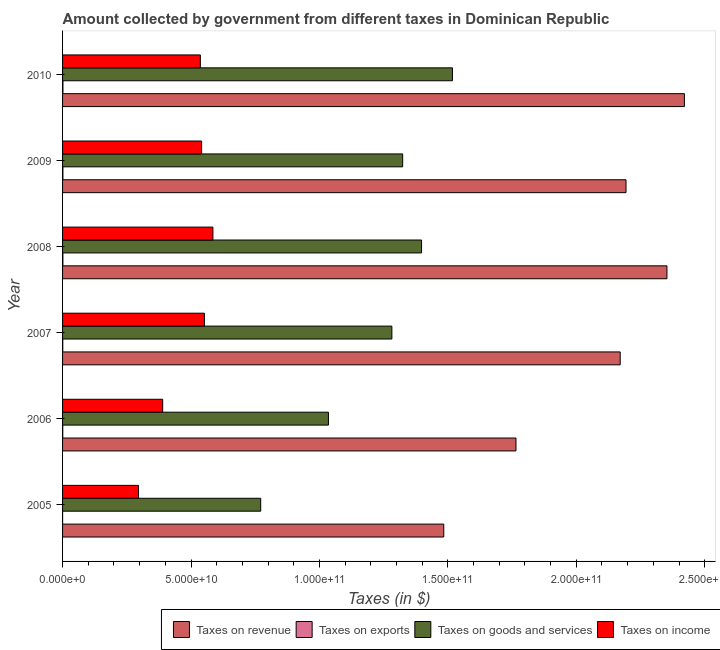How many groups of bars are there?
Give a very brief answer. 6. Are the number of bars per tick equal to the number of legend labels?
Your response must be concise. Yes. How many bars are there on the 3rd tick from the top?
Provide a short and direct response. 4. How many bars are there on the 6th tick from the bottom?
Provide a succinct answer. 4. What is the amount collected as tax on exports in 2008?
Offer a very short reply. 1.28e+08. Across all years, what is the maximum amount collected as tax on exports?
Keep it short and to the point. 1.46e+08. Across all years, what is the minimum amount collected as tax on revenue?
Provide a succinct answer. 1.48e+11. In which year was the amount collected as tax on exports maximum?
Provide a succinct answer. 2010. In which year was the amount collected as tax on income minimum?
Your answer should be compact. 2005. What is the total amount collected as tax on income in the graph?
Provide a succinct answer. 2.90e+11. What is the difference between the amount collected as tax on goods in 2005 and that in 2009?
Offer a terse response. -5.53e+1. What is the difference between the amount collected as tax on goods in 2006 and the amount collected as tax on income in 2008?
Your answer should be very brief. 4.50e+1. What is the average amount collected as tax on exports per year?
Make the answer very short. 9.52e+07. In the year 2010, what is the difference between the amount collected as tax on exports and amount collected as tax on revenue?
Make the answer very short. -2.42e+11. What is the ratio of the amount collected as tax on revenue in 2006 to that in 2010?
Your answer should be very brief. 0.73. Is the amount collected as tax on exports in 2008 less than that in 2009?
Offer a terse response. Yes. What is the difference between the highest and the second highest amount collected as tax on exports?
Provide a short and direct response. 1.46e+07. What is the difference between the highest and the lowest amount collected as tax on goods?
Give a very brief answer. 7.47e+1. Is the sum of the amount collected as tax on income in 2006 and 2010 greater than the maximum amount collected as tax on revenue across all years?
Your answer should be compact. No. Is it the case that in every year, the sum of the amount collected as tax on goods and amount collected as tax on revenue is greater than the sum of amount collected as tax on exports and amount collected as tax on income?
Offer a terse response. Yes. What does the 2nd bar from the top in 2006 represents?
Your answer should be very brief. Taxes on goods and services. What does the 3rd bar from the bottom in 2007 represents?
Your answer should be very brief. Taxes on goods and services. Is it the case that in every year, the sum of the amount collected as tax on revenue and amount collected as tax on exports is greater than the amount collected as tax on goods?
Provide a short and direct response. Yes. Are the values on the major ticks of X-axis written in scientific E-notation?
Your answer should be compact. Yes. Does the graph contain any zero values?
Ensure brevity in your answer.  No. Does the graph contain grids?
Ensure brevity in your answer.  No. How many legend labels are there?
Make the answer very short. 4. How are the legend labels stacked?
Provide a succinct answer. Horizontal. What is the title of the graph?
Your answer should be compact. Amount collected by government from different taxes in Dominican Republic. Does "Compensation of employees" appear as one of the legend labels in the graph?
Offer a terse response. No. What is the label or title of the X-axis?
Provide a short and direct response. Taxes (in $). What is the Taxes (in $) of Taxes on revenue in 2005?
Offer a terse response. 1.48e+11. What is the Taxes (in $) of Taxes on exports in 2005?
Give a very brief answer. 1.36e+07. What is the Taxes (in $) in Taxes on goods and services in 2005?
Provide a short and direct response. 7.71e+1. What is the Taxes (in $) in Taxes on income in 2005?
Your answer should be very brief. 2.96e+1. What is the Taxes (in $) of Taxes on revenue in 2006?
Make the answer very short. 1.77e+11. What is the Taxes (in $) in Taxes on exports in 2006?
Your answer should be very brief. 6.90e+07. What is the Taxes (in $) of Taxes on goods and services in 2006?
Your answer should be compact. 1.04e+11. What is the Taxes (in $) of Taxes on income in 2006?
Make the answer very short. 3.90e+1. What is the Taxes (in $) of Taxes on revenue in 2007?
Your response must be concise. 2.17e+11. What is the Taxes (in $) in Taxes on exports in 2007?
Your answer should be compact. 8.25e+07. What is the Taxes (in $) in Taxes on goods and services in 2007?
Offer a terse response. 1.28e+11. What is the Taxes (in $) of Taxes on income in 2007?
Offer a terse response. 5.52e+1. What is the Taxes (in $) of Taxes on revenue in 2008?
Your answer should be compact. 2.35e+11. What is the Taxes (in $) of Taxes on exports in 2008?
Offer a terse response. 1.28e+08. What is the Taxes (in $) in Taxes on goods and services in 2008?
Offer a terse response. 1.40e+11. What is the Taxes (in $) in Taxes on income in 2008?
Offer a very short reply. 5.85e+1. What is the Taxes (in $) in Taxes on revenue in 2009?
Provide a succinct answer. 2.19e+11. What is the Taxes (in $) in Taxes on exports in 2009?
Your answer should be very brief. 1.32e+08. What is the Taxes (in $) in Taxes on goods and services in 2009?
Offer a very short reply. 1.32e+11. What is the Taxes (in $) in Taxes on income in 2009?
Offer a terse response. 5.41e+1. What is the Taxes (in $) of Taxes on revenue in 2010?
Keep it short and to the point. 2.42e+11. What is the Taxes (in $) of Taxes on exports in 2010?
Ensure brevity in your answer.  1.46e+08. What is the Taxes (in $) in Taxes on goods and services in 2010?
Provide a short and direct response. 1.52e+11. What is the Taxes (in $) of Taxes on income in 2010?
Offer a terse response. 5.36e+1. Across all years, what is the maximum Taxes (in $) of Taxes on revenue?
Make the answer very short. 2.42e+11. Across all years, what is the maximum Taxes (in $) of Taxes on exports?
Ensure brevity in your answer.  1.46e+08. Across all years, what is the maximum Taxes (in $) of Taxes on goods and services?
Provide a succinct answer. 1.52e+11. Across all years, what is the maximum Taxes (in $) in Taxes on income?
Ensure brevity in your answer.  5.85e+1. Across all years, what is the minimum Taxes (in $) of Taxes on revenue?
Give a very brief answer. 1.48e+11. Across all years, what is the minimum Taxes (in $) in Taxes on exports?
Your answer should be very brief. 1.36e+07. Across all years, what is the minimum Taxes (in $) in Taxes on goods and services?
Your answer should be very brief. 7.71e+1. Across all years, what is the minimum Taxes (in $) in Taxes on income?
Your response must be concise. 2.96e+1. What is the total Taxes (in $) in Taxes on revenue in the graph?
Provide a succinct answer. 1.24e+12. What is the total Taxes (in $) of Taxes on exports in the graph?
Your response must be concise. 5.71e+08. What is the total Taxes (in $) in Taxes on goods and services in the graph?
Keep it short and to the point. 7.33e+11. What is the total Taxes (in $) of Taxes on income in the graph?
Offer a very short reply. 2.90e+11. What is the difference between the Taxes (in $) in Taxes on revenue in 2005 and that in 2006?
Offer a terse response. -2.81e+1. What is the difference between the Taxes (in $) in Taxes on exports in 2005 and that in 2006?
Your answer should be compact. -5.54e+07. What is the difference between the Taxes (in $) in Taxes on goods and services in 2005 and that in 2006?
Your answer should be very brief. -2.64e+1. What is the difference between the Taxes (in $) in Taxes on income in 2005 and that in 2006?
Ensure brevity in your answer.  -9.41e+09. What is the difference between the Taxes (in $) of Taxes on revenue in 2005 and that in 2007?
Your answer should be compact. -6.87e+1. What is the difference between the Taxes (in $) in Taxes on exports in 2005 and that in 2007?
Provide a succinct answer. -6.89e+07. What is the difference between the Taxes (in $) of Taxes on goods and services in 2005 and that in 2007?
Your answer should be very brief. -5.11e+1. What is the difference between the Taxes (in $) of Taxes on income in 2005 and that in 2007?
Give a very brief answer. -2.57e+1. What is the difference between the Taxes (in $) in Taxes on revenue in 2005 and that in 2008?
Make the answer very short. -8.69e+1. What is the difference between the Taxes (in $) in Taxes on exports in 2005 and that in 2008?
Offer a very short reply. -1.15e+08. What is the difference between the Taxes (in $) of Taxes on goods and services in 2005 and that in 2008?
Make the answer very short. -6.26e+1. What is the difference between the Taxes (in $) of Taxes on income in 2005 and that in 2008?
Offer a very short reply. -2.90e+1. What is the difference between the Taxes (in $) in Taxes on revenue in 2005 and that in 2009?
Your response must be concise. -7.10e+1. What is the difference between the Taxes (in $) in Taxes on exports in 2005 and that in 2009?
Make the answer very short. -1.18e+08. What is the difference between the Taxes (in $) in Taxes on goods and services in 2005 and that in 2009?
Ensure brevity in your answer.  -5.53e+1. What is the difference between the Taxes (in $) of Taxes on income in 2005 and that in 2009?
Make the answer very short. -2.46e+1. What is the difference between the Taxes (in $) of Taxes on revenue in 2005 and that in 2010?
Provide a short and direct response. -9.37e+1. What is the difference between the Taxes (in $) of Taxes on exports in 2005 and that in 2010?
Provide a succinct answer. -1.33e+08. What is the difference between the Taxes (in $) of Taxes on goods and services in 2005 and that in 2010?
Your response must be concise. -7.47e+1. What is the difference between the Taxes (in $) of Taxes on income in 2005 and that in 2010?
Your response must be concise. -2.41e+1. What is the difference between the Taxes (in $) in Taxes on revenue in 2006 and that in 2007?
Give a very brief answer. -4.06e+1. What is the difference between the Taxes (in $) of Taxes on exports in 2006 and that in 2007?
Make the answer very short. -1.35e+07. What is the difference between the Taxes (in $) of Taxes on goods and services in 2006 and that in 2007?
Your answer should be very brief. -2.47e+1. What is the difference between the Taxes (in $) of Taxes on income in 2006 and that in 2007?
Keep it short and to the point. -1.63e+1. What is the difference between the Taxes (in $) of Taxes on revenue in 2006 and that in 2008?
Your answer should be compact. -5.88e+1. What is the difference between the Taxes (in $) in Taxes on exports in 2006 and that in 2008?
Your response must be concise. -5.92e+07. What is the difference between the Taxes (in $) of Taxes on goods and services in 2006 and that in 2008?
Give a very brief answer. -3.62e+1. What is the difference between the Taxes (in $) in Taxes on income in 2006 and that in 2008?
Your answer should be very brief. -1.96e+1. What is the difference between the Taxes (in $) in Taxes on revenue in 2006 and that in 2009?
Your answer should be very brief. -4.28e+1. What is the difference between the Taxes (in $) in Taxes on exports in 2006 and that in 2009?
Give a very brief answer. -6.27e+07. What is the difference between the Taxes (in $) in Taxes on goods and services in 2006 and that in 2009?
Provide a short and direct response. -2.89e+1. What is the difference between the Taxes (in $) of Taxes on income in 2006 and that in 2009?
Offer a very short reply. -1.51e+1. What is the difference between the Taxes (in $) of Taxes on revenue in 2006 and that in 2010?
Ensure brevity in your answer.  -6.56e+1. What is the difference between the Taxes (in $) of Taxes on exports in 2006 and that in 2010?
Make the answer very short. -7.73e+07. What is the difference between the Taxes (in $) of Taxes on goods and services in 2006 and that in 2010?
Give a very brief answer. -4.83e+1. What is the difference between the Taxes (in $) of Taxes on income in 2006 and that in 2010?
Make the answer very short. -1.47e+1. What is the difference between the Taxes (in $) of Taxes on revenue in 2007 and that in 2008?
Your answer should be very brief. -1.82e+1. What is the difference between the Taxes (in $) of Taxes on exports in 2007 and that in 2008?
Make the answer very short. -4.56e+07. What is the difference between the Taxes (in $) of Taxes on goods and services in 2007 and that in 2008?
Ensure brevity in your answer.  -1.16e+1. What is the difference between the Taxes (in $) of Taxes on income in 2007 and that in 2008?
Your answer should be compact. -3.30e+09. What is the difference between the Taxes (in $) of Taxes on revenue in 2007 and that in 2009?
Ensure brevity in your answer.  -2.26e+09. What is the difference between the Taxes (in $) of Taxes on exports in 2007 and that in 2009?
Provide a succinct answer. -4.92e+07. What is the difference between the Taxes (in $) of Taxes on goods and services in 2007 and that in 2009?
Your response must be concise. -4.20e+09. What is the difference between the Taxes (in $) of Taxes on income in 2007 and that in 2009?
Ensure brevity in your answer.  1.10e+09. What is the difference between the Taxes (in $) in Taxes on revenue in 2007 and that in 2010?
Keep it short and to the point. -2.50e+1. What is the difference between the Taxes (in $) of Taxes on exports in 2007 and that in 2010?
Provide a short and direct response. -6.38e+07. What is the difference between the Taxes (in $) in Taxes on goods and services in 2007 and that in 2010?
Make the answer very short. -2.36e+1. What is the difference between the Taxes (in $) in Taxes on income in 2007 and that in 2010?
Ensure brevity in your answer.  1.59e+09. What is the difference between the Taxes (in $) in Taxes on revenue in 2008 and that in 2009?
Your answer should be compact. 1.59e+1. What is the difference between the Taxes (in $) in Taxes on exports in 2008 and that in 2009?
Your response must be concise. -3.52e+06. What is the difference between the Taxes (in $) in Taxes on goods and services in 2008 and that in 2009?
Provide a succinct answer. 7.36e+09. What is the difference between the Taxes (in $) in Taxes on income in 2008 and that in 2009?
Offer a very short reply. 4.41e+09. What is the difference between the Taxes (in $) of Taxes on revenue in 2008 and that in 2010?
Keep it short and to the point. -6.79e+09. What is the difference between the Taxes (in $) of Taxes on exports in 2008 and that in 2010?
Your answer should be very brief. -1.82e+07. What is the difference between the Taxes (in $) of Taxes on goods and services in 2008 and that in 2010?
Give a very brief answer. -1.20e+1. What is the difference between the Taxes (in $) of Taxes on income in 2008 and that in 2010?
Ensure brevity in your answer.  4.89e+09. What is the difference between the Taxes (in $) in Taxes on revenue in 2009 and that in 2010?
Offer a very short reply. -2.27e+1. What is the difference between the Taxes (in $) in Taxes on exports in 2009 and that in 2010?
Your response must be concise. -1.46e+07. What is the difference between the Taxes (in $) in Taxes on goods and services in 2009 and that in 2010?
Provide a short and direct response. -1.94e+1. What is the difference between the Taxes (in $) in Taxes on income in 2009 and that in 2010?
Ensure brevity in your answer.  4.84e+08. What is the difference between the Taxes (in $) in Taxes on revenue in 2005 and the Taxes (in $) in Taxes on exports in 2006?
Ensure brevity in your answer.  1.48e+11. What is the difference between the Taxes (in $) of Taxes on revenue in 2005 and the Taxes (in $) of Taxes on goods and services in 2006?
Keep it short and to the point. 4.49e+1. What is the difference between the Taxes (in $) in Taxes on revenue in 2005 and the Taxes (in $) in Taxes on income in 2006?
Your answer should be compact. 1.09e+11. What is the difference between the Taxes (in $) in Taxes on exports in 2005 and the Taxes (in $) in Taxes on goods and services in 2006?
Ensure brevity in your answer.  -1.04e+11. What is the difference between the Taxes (in $) of Taxes on exports in 2005 and the Taxes (in $) of Taxes on income in 2006?
Give a very brief answer. -3.90e+1. What is the difference between the Taxes (in $) of Taxes on goods and services in 2005 and the Taxes (in $) of Taxes on income in 2006?
Your response must be concise. 3.82e+1. What is the difference between the Taxes (in $) in Taxes on revenue in 2005 and the Taxes (in $) in Taxes on exports in 2007?
Keep it short and to the point. 1.48e+11. What is the difference between the Taxes (in $) of Taxes on revenue in 2005 and the Taxes (in $) of Taxes on goods and services in 2007?
Provide a short and direct response. 2.02e+1. What is the difference between the Taxes (in $) of Taxes on revenue in 2005 and the Taxes (in $) of Taxes on income in 2007?
Make the answer very short. 9.32e+1. What is the difference between the Taxes (in $) in Taxes on exports in 2005 and the Taxes (in $) in Taxes on goods and services in 2007?
Keep it short and to the point. -1.28e+11. What is the difference between the Taxes (in $) of Taxes on exports in 2005 and the Taxes (in $) of Taxes on income in 2007?
Your answer should be compact. -5.52e+1. What is the difference between the Taxes (in $) of Taxes on goods and services in 2005 and the Taxes (in $) of Taxes on income in 2007?
Give a very brief answer. 2.19e+1. What is the difference between the Taxes (in $) of Taxes on revenue in 2005 and the Taxes (in $) of Taxes on exports in 2008?
Ensure brevity in your answer.  1.48e+11. What is the difference between the Taxes (in $) in Taxes on revenue in 2005 and the Taxes (in $) in Taxes on goods and services in 2008?
Provide a short and direct response. 8.65e+09. What is the difference between the Taxes (in $) of Taxes on revenue in 2005 and the Taxes (in $) of Taxes on income in 2008?
Provide a short and direct response. 8.99e+1. What is the difference between the Taxes (in $) in Taxes on exports in 2005 and the Taxes (in $) in Taxes on goods and services in 2008?
Provide a succinct answer. -1.40e+11. What is the difference between the Taxes (in $) of Taxes on exports in 2005 and the Taxes (in $) of Taxes on income in 2008?
Offer a very short reply. -5.85e+1. What is the difference between the Taxes (in $) of Taxes on goods and services in 2005 and the Taxes (in $) of Taxes on income in 2008?
Ensure brevity in your answer.  1.86e+1. What is the difference between the Taxes (in $) of Taxes on revenue in 2005 and the Taxes (in $) of Taxes on exports in 2009?
Provide a short and direct response. 1.48e+11. What is the difference between the Taxes (in $) in Taxes on revenue in 2005 and the Taxes (in $) in Taxes on goods and services in 2009?
Keep it short and to the point. 1.60e+1. What is the difference between the Taxes (in $) of Taxes on revenue in 2005 and the Taxes (in $) of Taxes on income in 2009?
Provide a succinct answer. 9.43e+1. What is the difference between the Taxes (in $) of Taxes on exports in 2005 and the Taxes (in $) of Taxes on goods and services in 2009?
Offer a very short reply. -1.32e+11. What is the difference between the Taxes (in $) in Taxes on exports in 2005 and the Taxes (in $) in Taxes on income in 2009?
Offer a very short reply. -5.41e+1. What is the difference between the Taxes (in $) in Taxes on goods and services in 2005 and the Taxes (in $) in Taxes on income in 2009?
Your answer should be compact. 2.30e+1. What is the difference between the Taxes (in $) in Taxes on revenue in 2005 and the Taxes (in $) in Taxes on exports in 2010?
Your answer should be compact. 1.48e+11. What is the difference between the Taxes (in $) in Taxes on revenue in 2005 and the Taxes (in $) in Taxes on goods and services in 2010?
Your answer should be very brief. -3.39e+09. What is the difference between the Taxes (in $) in Taxes on revenue in 2005 and the Taxes (in $) in Taxes on income in 2010?
Offer a very short reply. 9.48e+1. What is the difference between the Taxes (in $) in Taxes on exports in 2005 and the Taxes (in $) in Taxes on goods and services in 2010?
Your answer should be compact. -1.52e+11. What is the difference between the Taxes (in $) of Taxes on exports in 2005 and the Taxes (in $) of Taxes on income in 2010?
Your answer should be very brief. -5.36e+1. What is the difference between the Taxes (in $) in Taxes on goods and services in 2005 and the Taxes (in $) in Taxes on income in 2010?
Your answer should be compact. 2.35e+1. What is the difference between the Taxes (in $) of Taxes on revenue in 2006 and the Taxes (in $) of Taxes on exports in 2007?
Make the answer very short. 1.76e+11. What is the difference between the Taxes (in $) of Taxes on revenue in 2006 and the Taxes (in $) of Taxes on goods and services in 2007?
Offer a terse response. 4.83e+1. What is the difference between the Taxes (in $) in Taxes on revenue in 2006 and the Taxes (in $) in Taxes on income in 2007?
Provide a short and direct response. 1.21e+11. What is the difference between the Taxes (in $) of Taxes on exports in 2006 and the Taxes (in $) of Taxes on goods and services in 2007?
Ensure brevity in your answer.  -1.28e+11. What is the difference between the Taxes (in $) of Taxes on exports in 2006 and the Taxes (in $) of Taxes on income in 2007?
Your response must be concise. -5.52e+1. What is the difference between the Taxes (in $) of Taxes on goods and services in 2006 and the Taxes (in $) of Taxes on income in 2007?
Give a very brief answer. 4.83e+1. What is the difference between the Taxes (in $) of Taxes on revenue in 2006 and the Taxes (in $) of Taxes on exports in 2008?
Keep it short and to the point. 1.76e+11. What is the difference between the Taxes (in $) of Taxes on revenue in 2006 and the Taxes (in $) of Taxes on goods and services in 2008?
Your answer should be compact. 3.68e+1. What is the difference between the Taxes (in $) in Taxes on revenue in 2006 and the Taxes (in $) in Taxes on income in 2008?
Provide a succinct answer. 1.18e+11. What is the difference between the Taxes (in $) in Taxes on exports in 2006 and the Taxes (in $) in Taxes on goods and services in 2008?
Keep it short and to the point. -1.40e+11. What is the difference between the Taxes (in $) in Taxes on exports in 2006 and the Taxes (in $) in Taxes on income in 2008?
Provide a succinct answer. -5.85e+1. What is the difference between the Taxes (in $) of Taxes on goods and services in 2006 and the Taxes (in $) of Taxes on income in 2008?
Your answer should be compact. 4.50e+1. What is the difference between the Taxes (in $) of Taxes on revenue in 2006 and the Taxes (in $) of Taxes on exports in 2009?
Keep it short and to the point. 1.76e+11. What is the difference between the Taxes (in $) of Taxes on revenue in 2006 and the Taxes (in $) of Taxes on goods and services in 2009?
Make the answer very short. 4.41e+1. What is the difference between the Taxes (in $) of Taxes on revenue in 2006 and the Taxes (in $) of Taxes on income in 2009?
Your response must be concise. 1.22e+11. What is the difference between the Taxes (in $) in Taxes on exports in 2006 and the Taxes (in $) in Taxes on goods and services in 2009?
Provide a succinct answer. -1.32e+11. What is the difference between the Taxes (in $) in Taxes on exports in 2006 and the Taxes (in $) in Taxes on income in 2009?
Ensure brevity in your answer.  -5.41e+1. What is the difference between the Taxes (in $) of Taxes on goods and services in 2006 and the Taxes (in $) of Taxes on income in 2009?
Your answer should be compact. 4.94e+1. What is the difference between the Taxes (in $) in Taxes on revenue in 2006 and the Taxes (in $) in Taxes on exports in 2010?
Offer a very short reply. 1.76e+11. What is the difference between the Taxes (in $) in Taxes on revenue in 2006 and the Taxes (in $) in Taxes on goods and services in 2010?
Keep it short and to the point. 2.47e+1. What is the difference between the Taxes (in $) in Taxes on revenue in 2006 and the Taxes (in $) in Taxes on income in 2010?
Your answer should be compact. 1.23e+11. What is the difference between the Taxes (in $) of Taxes on exports in 2006 and the Taxes (in $) of Taxes on goods and services in 2010?
Your answer should be compact. -1.52e+11. What is the difference between the Taxes (in $) of Taxes on exports in 2006 and the Taxes (in $) of Taxes on income in 2010?
Provide a short and direct response. -5.36e+1. What is the difference between the Taxes (in $) of Taxes on goods and services in 2006 and the Taxes (in $) of Taxes on income in 2010?
Offer a very short reply. 4.99e+1. What is the difference between the Taxes (in $) in Taxes on revenue in 2007 and the Taxes (in $) in Taxes on exports in 2008?
Your answer should be very brief. 2.17e+11. What is the difference between the Taxes (in $) in Taxes on revenue in 2007 and the Taxes (in $) in Taxes on goods and services in 2008?
Your answer should be compact. 7.73e+1. What is the difference between the Taxes (in $) of Taxes on revenue in 2007 and the Taxes (in $) of Taxes on income in 2008?
Give a very brief answer. 1.59e+11. What is the difference between the Taxes (in $) in Taxes on exports in 2007 and the Taxes (in $) in Taxes on goods and services in 2008?
Your response must be concise. -1.40e+11. What is the difference between the Taxes (in $) in Taxes on exports in 2007 and the Taxes (in $) in Taxes on income in 2008?
Offer a very short reply. -5.85e+1. What is the difference between the Taxes (in $) of Taxes on goods and services in 2007 and the Taxes (in $) of Taxes on income in 2008?
Your answer should be very brief. 6.97e+1. What is the difference between the Taxes (in $) of Taxes on revenue in 2007 and the Taxes (in $) of Taxes on exports in 2009?
Provide a short and direct response. 2.17e+11. What is the difference between the Taxes (in $) of Taxes on revenue in 2007 and the Taxes (in $) of Taxes on goods and services in 2009?
Offer a terse response. 8.47e+1. What is the difference between the Taxes (in $) of Taxes on revenue in 2007 and the Taxes (in $) of Taxes on income in 2009?
Your answer should be compact. 1.63e+11. What is the difference between the Taxes (in $) in Taxes on exports in 2007 and the Taxes (in $) in Taxes on goods and services in 2009?
Provide a succinct answer. -1.32e+11. What is the difference between the Taxes (in $) of Taxes on exports in 2007 and the Taxes (in $) of Taxes on income in 2009?
Your response must be concise. -5.40e+1. What is the difference between the Taxes (in $) in Taxes on goods and services in 2007 and the Taxes (in $) in Taxes on income in 2009?
Provide a succinct answer. 7.41e+1. What is the difference between the Taxes (in $) in Taxes on revenue in 2007 and the Taxes (in $) in Taxes on exports in 2010?
Offer a terse response. 2.17e+11. What is the difference between the Taxes (in $) in Taxes on revenue in 2007 and the Taxes (in $) in Taxes on goods and services in 2010?
Give a very brief answer. 6.53e+1. What is the difference between the Taxes (in $) of Taxes on revenue in 2007 and the Taxes (in $) of Taxes on income in 2010?
Make the answer very short. 1.63e+11. What is the difference between the Taxes (in $) in Taxes on exports in 2007 and the Taxes (in $) in Taxes on goods and services in 2010?
Keep it short and to the point. -1.52e+11. What is the difference between the Taxes (in $) of Taxes on exports in 2007 and the Taxes (in $) of Taxes on income in 2010?
Provide a short and direct response. -5.36e+1. What is the difference between the Taxes (in $) in Taxes on goods and services in 2007 and the Taxes (in $) in Taxes on income in 2010?
Your answer should be very brief. 7.46e+1. What is the difference between the Taxes (in $) of Taxes on revenue in 2008 and the Taxes (in $) of Taxes on exports in 2009?
Your answer should be very brief. 2.35e+11. What is the difference between the Taxes (in $) of Taxes on revenue in 2008 and the Taxes (in $) of Taxes on goods and services in 2009?
Offer a very short reply. 1.03e+11. What is the difference between the Taxes (in $) of Taxes on revenue in 2008 and the Taxes (in $) of Taxes on income in 2009?
Offer a very short reply. 1.81e+11. What is the difference between the Taxes (in $) in Taxes on exports in 2008 and the Taxes (in $) in Taxes on goods and services in 2009?
Your response must be concise. -1.32e+11. What is the difference between the Taxes (in $) of Taxes on exports in 2008 and the Taxes (in $) of Taxes on income in 2009?
Make the answer very short. -5.40e+1. What is the difference between the Taxes (in $) of Taxes on goods and services in 2008 and the Taxes (in $) of Taxes on income in 2009?
Offer a terse response. 8.56e+1. What is the difference between the Taxes (in $) in Taxes on revenue in 2008 and the Taxes (in $) in Taxes on exports in 2010?
Offer a very short reply. 2.35e+11. What is the difference between the Taxes (in $) of Taxes on revenue in 2008 and the Taxes (in $) of Taxes on goods and services in 2010?
Keep it short and to the point. 8.35e+1. What is the difference between the Taxes (in $) of Taxes on revenue in 2008 and the Taxes (in $) of Taxes on income in 2010?
Make the answer very short. 1.82e+11. What is the difference between the Taxes (in $) in Taxes on exports in 2008 and the Taxes (in $) in Taxes on goods and services in 2010?
Your answer should be compact. -1.52e+11. What is the difference between the Taxes (in $) in Taxes on exports in 2008 and the Taxes (in $) in Taxes on income in 2010?
Your response must be concise. -5.35e+1. What is the difference between the Taxes (in $) of Taxes on goods and services in 2008 and the Taxes (in $) of Taxes on income in 2010?
Offer a very short reply. 8.61e+1. What is the difference between the Taxes (in $) in Taxes on revenue in 2009 and the Taxes (in $) in Taxes on exports in 2010?
Provide a succinct answer. 2.19e+11. What is the difference between the Taxes (in $) of Taxes on revenue in 2009 and the Taxes (in $) of Taxes on goods and services in 2010?
Offer a very short reply. 6.76e+1. What is the difference between the Taxes (in $) of Taxes on revenue in 2009 and the Taxes (in $) of Taxes on income in 2010?
Make the answer very short. 1.66e+11. What is the difference between the Taxes (in $) of Taxes on exports in 2009 and the Taxes (in $) of Taxes on goods and services in 2010?
Keep it short and to the point. -1.52e+11. What is the difference between the Taxes (in $) of Taxes on exports in 2009 and the Taxes (in $) of Taxes on income in 2010?
Offer a very short reply. -5.35e+1. What is the difference between the Taxes (in $) of Taxes on goods and services in 2009 and the Taxes (in $) of Taxes on income in 2010?
Offer a terse response. 7.88e+1. What is the average Taxes (in $) of Taxes on revenue per year?
Ensure brevity in your answer.  2.06e+11. What is the average Taxes (in $) in Taxes on exports per year?
Offer a terse response. 9.52e+07. What is the average Taxes (in $) in Taxes on goods and services per year?
Make the answer very short. 1.22e+11. What is the average Taxes (in $) of Taxes on income per year?
Your answer should be compact. 4.83e+1. In the year 2005, what is the difference between the Taxes (in $) of Taxes on revenue and Taxes (in $) of Taxes on exports?
Your response must be concise. 1.48e+11. In the year 2005, what is the difference between the Taxes (in $) in Taxes on revenue and Taxes (in $) in Taxes on goods and services?
Provide a succinct answer. 7.13e+1. In the year 2005, what is the difference between the Taxes (in $) in Taxes on revenue and Taxes (in $) in Taxes on income?
Your response must be concise. 1.19e+11. In the year 2005, what is the difference between the Taxes (in $) of Taxes on exports and Taxes (in $) of Taxes on goods and services?
Offer a very short reply. -7.71e+1. In the year 2005, what is the difference between the Taxes (in $) of Taxes on exports and Taxes (in $) of Taxes on income?
Make the answer very short. -2.96e+1. In the year 2005, what is the difference between the Taxes (in $) in Taxes on goods and services and Taxes (in $) in Taxes on income?
Offer a very short reply. 4.76e+1. In the year 2006, what is the difference between the Taxes (in $) in Taxes on revenue and Taxes (in $) in Taxes on exports?
Offer a terse response. 1.76e+11. In the year 2006, what is the difference between the Taxes (in $) of Taxes on revenue and Taxes (in $) of Taxes on goods and services?
Provide a short and direct response. 7.30e+1. In the year 2006, what is the difference between the Taxes (in $) of Taxes on revenue and Taxes (in $) of Taxes on income?
Provide a short and direct response. 1.38e+11. In the year 2006, what is the difference between the Taxes (in $) of Taxes on exports and Taxes (in $) of Taxes on goods and services?
Offer a very short reply. -1.03e+11. In the year 2006, what is the difference between the Taxes (in $) of Taxes on exports and Taxes (in $) of Taxes on income?
Provide a succinct answer. -3.89e+1. In the year 2006, what is the difference between the Taxes (in $) in Taxes on goods and services and Taxes (in $) in Taxes on income?
Make the answer very short. 6.45e+1. In the year 2007, what is the difference between the Taxes (in $) in Taxes on revenue and Taxes (in $) in Taxes on exports?
Make the answer very short. 2.17e+11. In the year 2007, what is the difference between the Taxes (in $) of Taxes on revenue and Taxes (in $) of Taxes on goods and services?
Offer a terse response. 8.89e+1. In the year 2007, what is the difference between the Taxes (in $) in Taxes on revenue and Taxes (in $) in Taxes on income?
Offer a very short reply. 1.62e+11. In the year 2007, what is the difference between the Taxes (in $) of Taxes on exports and Taxes (in $) of Taxes on goods and services?
Keep it short and to the point. -1.28e+11. In the year 2007, what is the difference between the Taxes (in $) of Taxes on exports and Taxes (in $) of Taxes on income?
Offer a very short reply. -5.51e+1. In the year 2007, what is the difference between the Taxes (in $) of Taxes on goods and services and Taxes (in $) of Taxes on income?
Keep it short and to the point. 7.30e+1. In the year 2008, what is the difference between the Taxes (in $) of Taxes on revenue and Taxes (in $) of Taxes on exports?
Give a very brief answer. 2.35e+11. In the year 2008, what is the difference between the Taxes (in $) of Taxes on revenue and Taxes (in $) of Taxes on goods and services?
Offer a terse response. 9.55e+1. In the year 2008, what is the difference between the Taxes (in $) in Taxes on revenue and Taxes (in $) in Taxes on income?
Keep it short and to the point. 1.77e+11. In the year 2008, what is the difference between the Taxes (in $) of Taxes on exports and Taxes (in $) of Taxes on goods and services?
Your response must be concise. -1.40e+11. In the year 2008, what is the difference between the Taxes (in $) in Taxes on exports and Taxes (in $) in Taxes on income?
Keep it short and to the point. -5.84e+1. In the year 2008, what is the difference between the Taxes (in $) of Taxes on goods and services and Taxes (in $) of Taxes on income?
Provide a short and direct response. 8.12e+1. In the year 2009, what is the difference between the Taxes (in $) of Taxes on revenue and Taxes (in $) of Taxes on exports?
Provide a short and direct response. 2.19e+11. In the year 2009, what is the difference between the Taxes (in $) in Taxes on revenue and Taxes (in $) in Taxes on goods and services?
Keep it short and to the point. 8.70e+1. In the year 2009, what is the difference between the Taxes (in $) in Taxes on revenue and Taxes (in $) in Taxes on income?
Keep it short and to the point. 1.65e+11. In the year 2009, what is the difference between the Taxes (in $) in Taxes on exports and Taxes (in $) in Taxes on goods and services?
Your answer should be very brief. -1.32e+11. In the year 2009, what is the difference between the Taxes (in $) in Taxes on exports and Taxes (in $) in Taxes on income?
Offer a terse response. -5.40e+1. In the year 2009, what is the difference between the Taxes (in $) of Taxes on goods and services and Taxes (in $) of Taxes on income?
Make the answer very short. 7.83e+1. In the year 2010, what is the difference between the Taxes (in $) in Taxes on revenue and Taxes (in $) in Taxes on exports?
Give a very brief answer. 2.42e+11. In the year 2010, what is the difference between the Taxes (in $) in Taxes on revenue and Taxes (in $) in Taxes on goods and services?
Make the answer very short. 9.03e+1. In the year 2010, what is the difference between the Taxes (in $) in Taxes on revenue and Taxes (in $) in Taxes on income?
Make the answer very short. 1.88e+11. In the year 2010, what is the difference between the Taxes (in $) in Taxes on exports and Taxes (in $) in Taxes on goods and services?
Ensure brevity in your answer.  -1.52e+11. In the year 2010, what is the difference between the Taxes (in $) in Taxes on exports and Taxes (in $) in Taxes on income?
Make the answer very short. -5.35e+1. In the year 2010, what is the difference between the Taxes (in $) in Taxes on goods and services and Taxes (in $) in Taxes on income?
Ensure brevity in your answer.  9.82e+1. What is the ratio of the Taxes (in $) of Taxes on revenue in 2005 to that in 2006?
Make the answer very short. 0.84. What is the ratio of the Taxes (in $) of Taxes on exports in 2005 to that in 2006?
Your answer should be compact. 0.2. What is the ratio of the Taxes (in $) of Taxes on goods and services in 2005 to that in 2006?
Offer a terse response. 0.75. What is the ratio of the Taxes (in $) of Taxes on income in 2005 to that in 2006?
Give a very brief answer. 0.76. What is the ratio of the Taxes (in $) of Taxes on revenue in 2005 to that in 2007?
Provide a short and direct response. 0.68. What is the ratio of the Taxes (in $) of Taxes on exports in 2005 to that in 2007?
Offer a terse response. 0.16. What is the ratio of the Taxes (in $) of Taxes on goods and services in 2005 to that in 2007?
Your answer should be compact. 0.6. What is the ratio of the Taxes (in $) in Taxes on income in 2005 to that in 2007?
Your answer should be compact. 0.54. What is the ratio of the Taxes (in $) in Taxes on revenue in 2005 to that in 2008?
Your answer should be compact. 0.63. What is the ratio of the Taxes (in $) of Taxes on exports in 2005 to that in 2008?
Your answer should be compact. 0.11. What is the ratio of the Taxes (in $) of Taxes on goods and services in 2005 to that in 2008?
Offer a terse response. 0.55. What is the ratio of the Taxes (in $) of Taxes on income in 2005 to that in 2008?
Provide a short and direct response. 0.51. What is the ratio of the Taxes (in $) of Taxes on revenue in 2005 to that in 2009?
Give a very brief answer. 0.68. What is the ratio of the Taxes (in $) of Taxes on exports in 2005 to that in 2009?
Offer a terse response. 0.1. What is the ratio of the Taxes (in $) of Taxes on goods and services in 2005 to that in 2009?
Your answer should be very brief. 0.58. What is the ratio of the Taxes (in $) of Taxes on income in 2005 to that in 2009?
Your response must be concise. 0.55. What is the ratio of the Taxes (in $) in Taxes on revenue in 2005 to that in 2010?
Ensure brevity in your answer.  0.61. What is the ratio of the Taxes (in $) in Taxes on exports in 2005 to that in 2010?
Your answer should be compact. 0.09. What is the ratio of the Taxes (in $) in Taxes on goods and services in 2005 to that in 2010?
Your response must be concise. 0.51. What is the ratio of the Taxes (in $) in Taxes on income in 2005 to that in 2010?
Your answer should be compact. 0.55. What is the ratio of the Taxes (in $) in Taxes on revenue in 2006 to that in 2007?
Your response must be concise. 0.81. What is the ratio of the Taxes (in $) of Taxes on exports in 2006 to that in 2007?
Ensure brevity in your answer.  0.84. What is the ratio of the Taxes (in $) of Taxes on goods and services in 2006 to that in 2007?
Your answer should be compact. 0.81. What is the ratio of the Taxes (in $) in Taxes on income in 2006 to that in 2007?
Make the answer very short. 0.71. What is the ratio of the Taxes (in $) in Taxes on revenue in 2006 to that in 2008?
Make the answer very short. 0.75. What is the ratio of the Taxes (in $) in Taxes on exports in 2006 to that in 2008?
Provide a short and direct response. 0.54. What is the ratio of the Taxes (in $) of Taxes on goods and services in 2006 to that in 2008?
Your answer should be compact. 0.74. What is the ratio of the Taxes (in $) in Taxes on income in 2006 to that in 2008?
Give a very brief answer. 0.67. What is the ratio of the Taxes (in $) in Taxes on revenue in 2006 to that in 2009?
Offer a terse response. 0.8. What is the ratio of the Taxes (in $) of Taxes on exports in 2006 to that in 2009?
Your response must be concise. 0.52. What is the ratio of the Taxes (in $) in Taxes on goods and services in 2006 to that in 2009?
Provide a succinct answer. 0.78. What is the ratio of the Taxes (in $) of Taxes on income in 2006 to that in 2009?
Your answer should be compact. 0.72. What is the ratio of the Taxes (in $) of Taxes on revenue in 2006 to that in 2010?
Your answer should be compact. 0.73. What is the ratio of the Taxes (in $) in Taxes on exports in 2006 to that in 2010?
Offer a very short reply. 0.47. What is the ratio of the Taxes (in $) in Taxes on goods and services in 2006 to that in 2010?
Offer a terse response. 0.68. What is the ratio of the Taxes (in $) in Taxes on income in 2006 to that in 2010?
Give a very brief answer. 0.73. What is the ratio of the Taxes (in $) in Taxes on revenue in 2007 to that in 2008?
Offer a terse response. 0.92. What is the ratio of the Taxes (in $) of Taxes on exports in 2007 to that in 2008?
Your response must be concise. 0.64. What is the ratio of the Taxes (in $) in Taxes on goods and services in 2007 to that in 2008?
Provide a short and direct response. 0.92. What is the ratio of the Taxes (in $) in Taxes on income in 2007 to that in 2008?
Your response must be concise. 0.94. What is the ratio of the Taxes (in $) in Taxes on exports in 2007 to that in 2009?
Offer a very short reply. 0.63. What is the ratio of the Taxes (in $) of Taxes on goods and services in 2007 to that in 2009?
Give a very brief answer. 0.97. What is the ratio of the Taxes (in $) of Taxes on income in 2007 to that in 2009?
Make the answer very short. 1.02. What is the ratio of the Taxes (in $) of Taxes on revenue in 2007 to that in 2010?
Your answer should be very brief. 0.9. What is the ratio of the Taxes (in $) of Taxes on exports in 2007 to that in 2010?
Give a very brief answer. 0.56. What is the ratio of the Taxes (in $) in Taxes on goods and services in 2007 to that in 2010?
Give a very brief answer. 0.84. What is the ratio of the Taxes (in $) of Taxes on income in 2007 to that in 2010?
Your answer should be compact. 1.03. What is the ratio of the Taxes (in $) of Taxes on revenue in 2008 to that in 2009?
Offer a very short reply. 1.07. What is the ratio of the Taxes (in $) in Taxes on exports in 2008 to that in 2009?
Make the answer very short. 0.97. What is the ratio of the Taxes (in $) in Taxes on goods and services in 2008 to that in 2009?
Your answer should be very brief. 1.06. What is the ratio of the Taxes (in $) in Taxes on income in 2008 to that in 2009?
Ensure brevity in your answer.  1.08. What is the ratio of the Taxes (in $) in Taxes on revenue in 2008 to that in 2010?
Offer a terse response. 0.97. What is the ratio of the Taxes (in $) in Taxes on exports in 2008 to that in 2010?
Make the answer very short. 0.88. What is the ratio of the Taxes (in $) in Taxes on goods and services in 2008 to that in 2010?
Make the answer very short. 0.92. What is the ratio of the Taxes (in $) in Taxes on income in 2008 to that in 2010?
Offer a very short reply. 1.09. What is the ratio of the Taxes (in $) in Taxes on revenue in 2009 to that in 2010?
Keep it short and to the point. 0.91. What is the ratio of the Taxes (in $) of Taxes on exports in 2009 to that in 2010?
Make the answer very short. 0.9. What is the ratio of the Taxes (in $) of Taxes on goods and services in 2009 to that in 2010?
Provide a succinct answer. 0.87. What is the ratio of the Taxes (in $) in Taxes on income in 2009 to that in 2010?
Offer a terse response. 1.01. What is the difference between the highest and the second highest Taxes (in $) in Taxes on revenue?
Your response must be concise. 6.79e+09. What is the difference between the highest and the second highest Taxes (in $) in Taxes on exports?
Provide a short and direct response. 1.46e+07. What is the difference between the highest and the second highest Taxes (in $) of Taxes on goods and services?
Make the answer very short. 1.20e+1. What is the difference between the highest and the second highest Taxes (in $) in Taxes on income?
Provide a short and direct response. 3.30e+09. What is the difference between the highest and the lowest Taxes (in $) in Taxes on revenue?
Offer a very short reply. 9.37e+1. What is the difference between the highest and the lowest Taxes (in $) in Taxes on exports?
Your answer should be compact. 1.33e+08. What is the difference between the highest and the lowest Taxes (in $) of Taxes on goods and services?
Offer a very short reply. 7.47e+1. What is the difference between the highest and the lowest Taxes (in $) in Taxes on income?
Offer a terse response. 2.90e+1. 